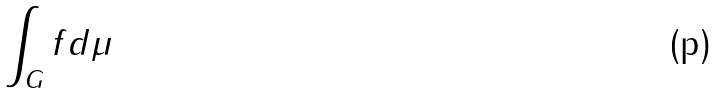Convert formula to latex. <formula><loc_0><loc_0><loc_500><loc_500>\int _ { G } f d \mu</formula> 